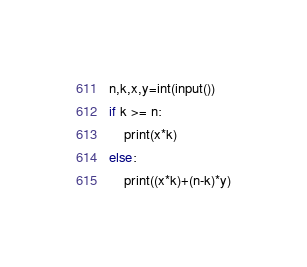Convert code to text. <code><loc_0><loc_0><loc_500><loc_500><_Python_>n,k,x,y=int(input())
if k >= n:
    print(x*k)
else:
    print((x*k)+(n-k)*y)
</code> 